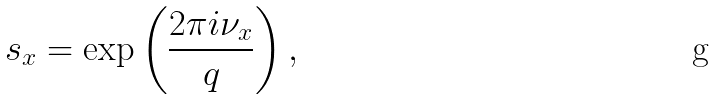Convert formula to latex. <formula><loc_0><loc_0><loc_500><loc_500>\ s _ { x } = \exp \left ( \frac { 2 \pi i \nu _ { x } } { q } \right ) ,</formula> 